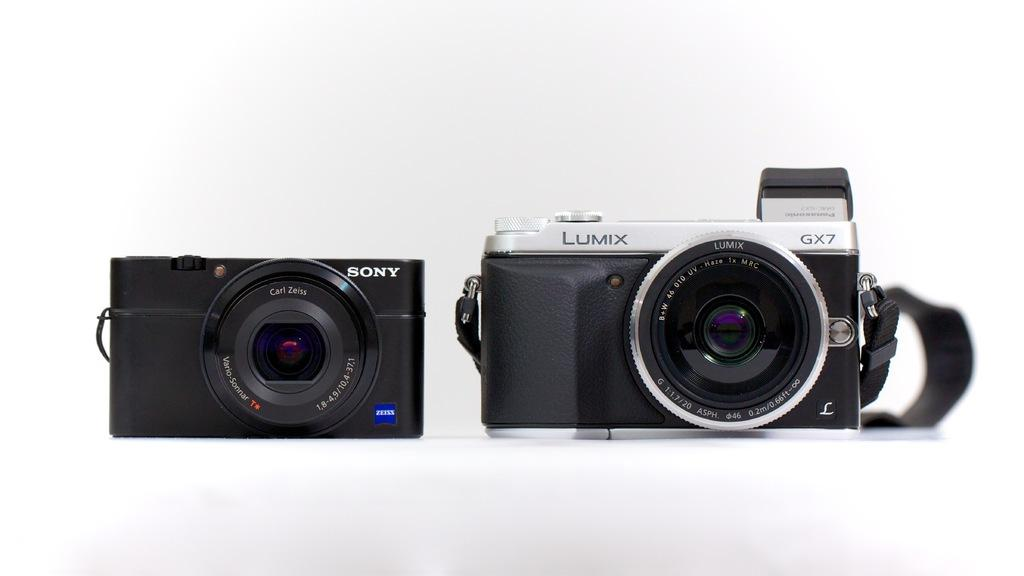What objects are present in the image? There are two cameras in the image. What additional detail can be observed about the cameras? There are names on the cameras. How many snakes can be seen slithering through the grass in the image? There are no snakes or grass present in the image; it features two cameras with names on them. What year is depicted in the image? The image does not depict a specific year; it only shows two cameras with names on them. 